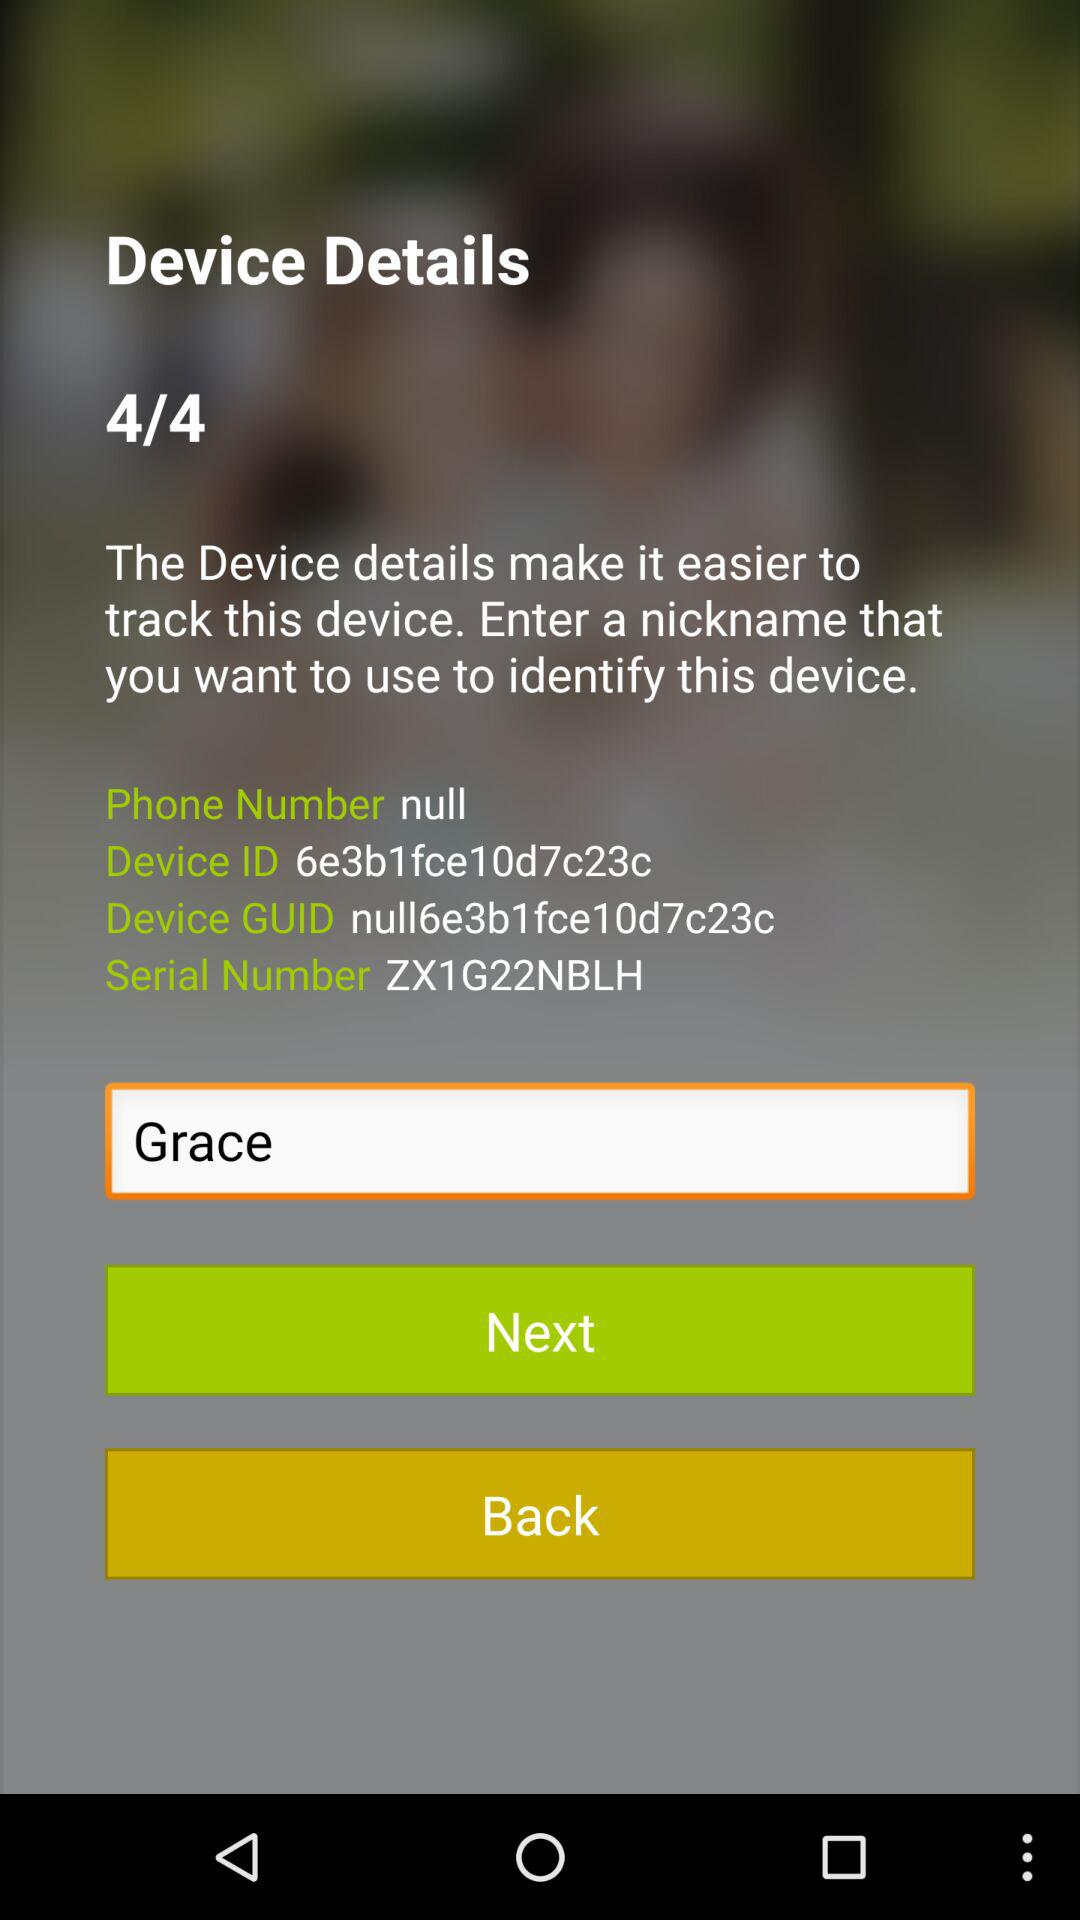What is the entered nickname for the device? The entered nickname is "Grace". 